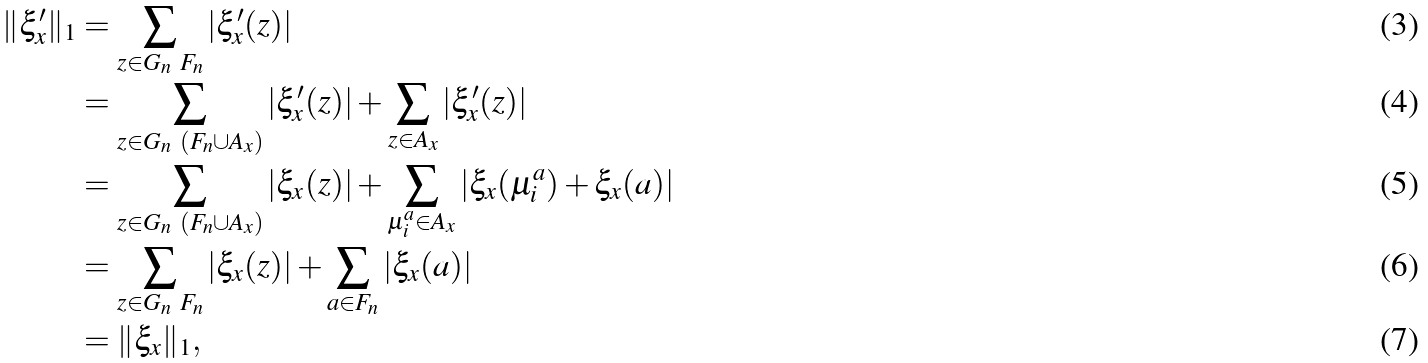Convert formula to latex. <formula><loc_0><loc_0><loc_500><loc_500>\| \xi _ { x } ^ { \prime } \| _ { 1 } & = \sum _ { z \in G _ { n } \ F _ { n } } | \xi ^ { \prime } _ { x } ( z ) | \\ & = \sum _ { z \in G _ { n } \ ( F _ { n } \cup A _ { x } ) } | \xi _ { x } ^ { \prime } ( z ) | + \sum _ { z \in A _ { x } } | \xi _ { x } ^ { \prime } ( z ) | \\ & = \sum _ { z \in G _ { n } \ ( F _ { n } \cup A _ { x } ) } | \xi _ { x } ( z ) | + \sum _ { \mu _ { i } ^ { a } \in A _ { x } } | \xi _ { x } ( \mu _ { i } ^ { a } ) + \xi _ { x } ( a ) | \\ & = \sum _ { z \in G _ { n } \ F _ { n } } | \xi _ { x } ( z ) | + \sum _ { a \in F _ { n } } | \xi _ { x } ( a ) | \\ & = \| \xi _ { x } \| _ { 1 } ,</formula> 